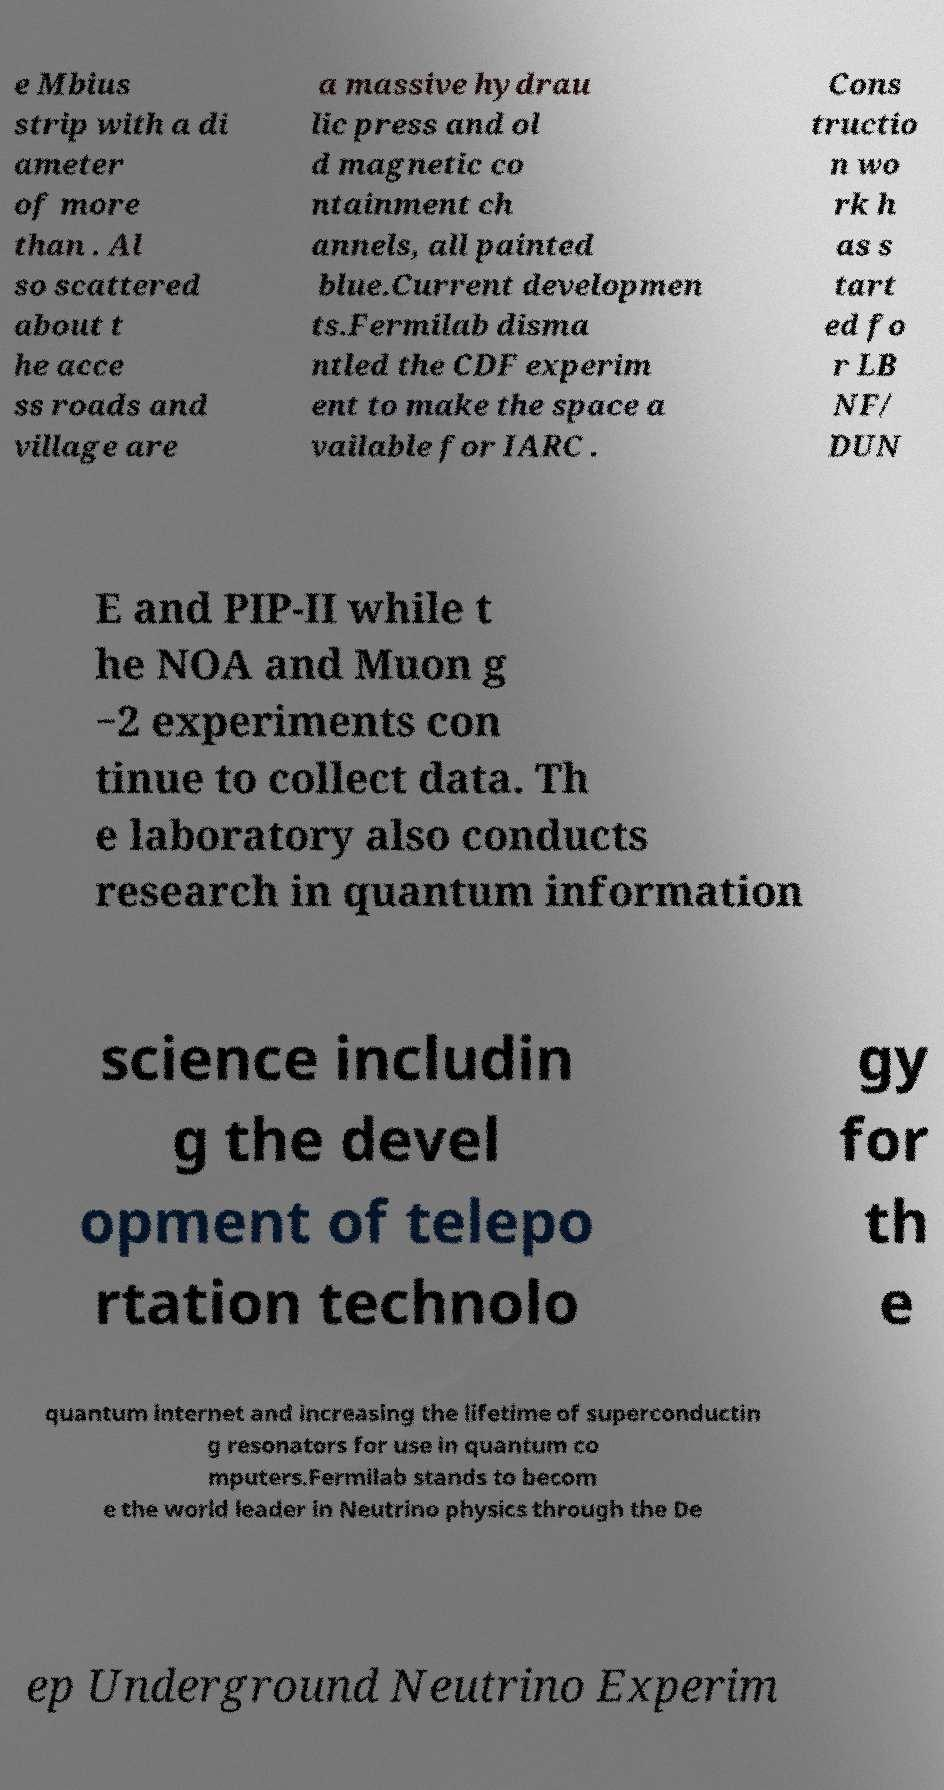Can you accurately transcribe the text from the provided image for me? e Mbius strip with a di ameter of more than . Al so scattered about t he acce ss roads and village are a massive hydrau lic press and ol d magnetic co ntainment ch annels, all painted blue.Current developmen ts.Fermilab disma ntled the CDF experim ent to make the space a vailable for IARC . Cons tructio n wo rk h as s tart ed fo r LB NF/ DUN E and PIP-II while t he NOA and Muon g −2 experiments con tinue to collect data. Th e laboratory also conducts research in quantum information science includin g the devel opment of telepo rtation technolo gy for th e quantum internet and increasing the lifetime of superconductin g resonators for use in quantum co mputers.Fermilab stands to becom e the world leader in Neutrino physics through the De ep Underground Neutrino Experim 